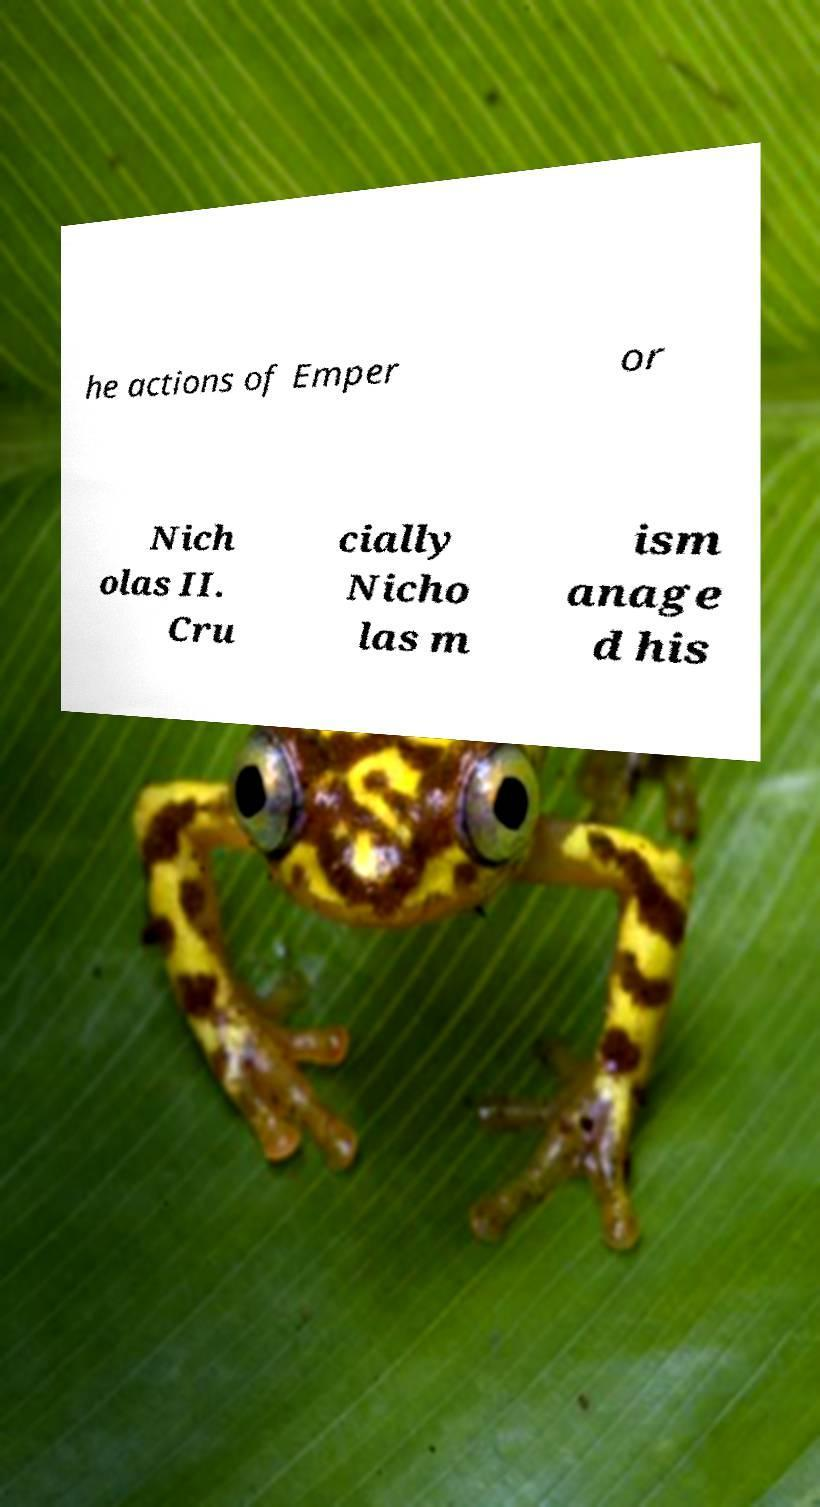Can you accurately transcribe the text from the provided image for me? he actions of Emper or Nich olas II. Cru cially Nicho las m ism anage d his 